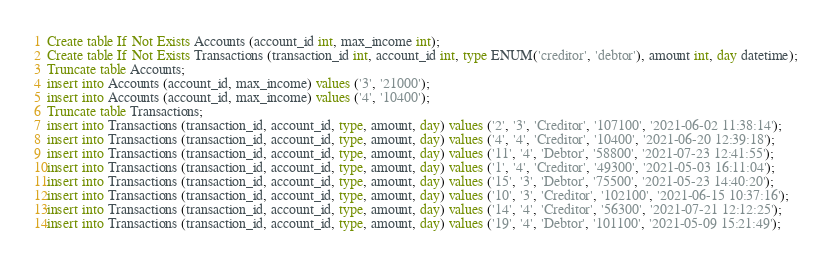Convert code to text. <code><loc_0><loc_0><loc_500><loc_500><_SQL_>Create table If Not Exists Accounts (account_id int, max_income int);
Create table If Not Exists Transactions (transaction_id int, account_id int, type ENUM('creditor', 'debtor'), amount int, day datetime);
Truncate table Accounts;
insert into Accounts (account_id, max_income) values ('3', '21000');
insert into Accounts (account_id, max_income) values ('4', '10400');
Truncate table Transactions;
insert into Transactions (transaction_id, account_id, type, amount, day) values ('2', '3', 'Creditor', '107100', '2021-06-02 11:38:14');
insert into Transactions (transaction_id, account_id, type, amount, day) values ('4', '4', 'Creditor', '10400', '2021-06-20 12:39:18');
insert into Transactions (transaction_id, account_id, type, amount, day) values ('11', '4', 'Debtor', '58800', '2021-07-23 12:41:55');
insert into Transactions (transaction_id, account_id, type, amount, day) values ('1', '4', 'Creditor', '49300', '2021-05-03 16:11:04');
insert into Transactions (transaction_id, account_id, type, amount, day) values ('15', '3', 'Debtor', '75500', '2021-05-23 14:40:20');
insert into Transactions (transaction_id, account_id, type, amount, day) values ('10', '3', 'Creditor', '102100', '2021-06-15 10:37:16');
insert into Transactions (transaction_id, account_id, type, amount, day) values ('14', '4', 'Creditor', '56300', '2021-07-21 12:12:25');
insert into Transactions (transaction_id, account_id, type, amount, day) values ('19', '4', 'Debtor', '101100', '2021-05-09 15:21:49');</code> 